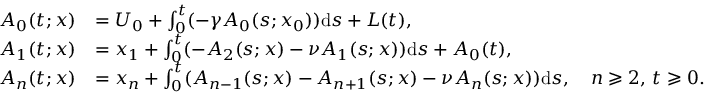<formula> <loc_0><loc_0><loc_500><loc_500>\begin{array} { r l } { A _ { 0 } ( t ; x ) } & { = U _ { 0 } + \int _ { 0 } ^ { t } ( - \gamma A _ { 0 } ( s ; x _ { 0 } ) ) d s + L ( t ) , } \\ { A _ { 1 } ( t ; x ) } & { = x _ { 1 } + \int _ { 0 } ^ { t } ( - A _ { 2 } ( s ; x ) - \nu A _ { 1 } ( s ; x ) ) d s + A _ { 0 } ( t ) , } \\ { A _ { n } ( t ; x ) } & { = x _ { n } + \int _ { 0 } ^ { t } ( { A _ { n - 1 } ( s ; x ) } - A _ { n + 1 } ( s ; x ) - \nu A _ { n } ( s ; x ) ) d s , \quad n \geqslant 2 , \, t \geqslant 0 . } \end{array}</formula> 